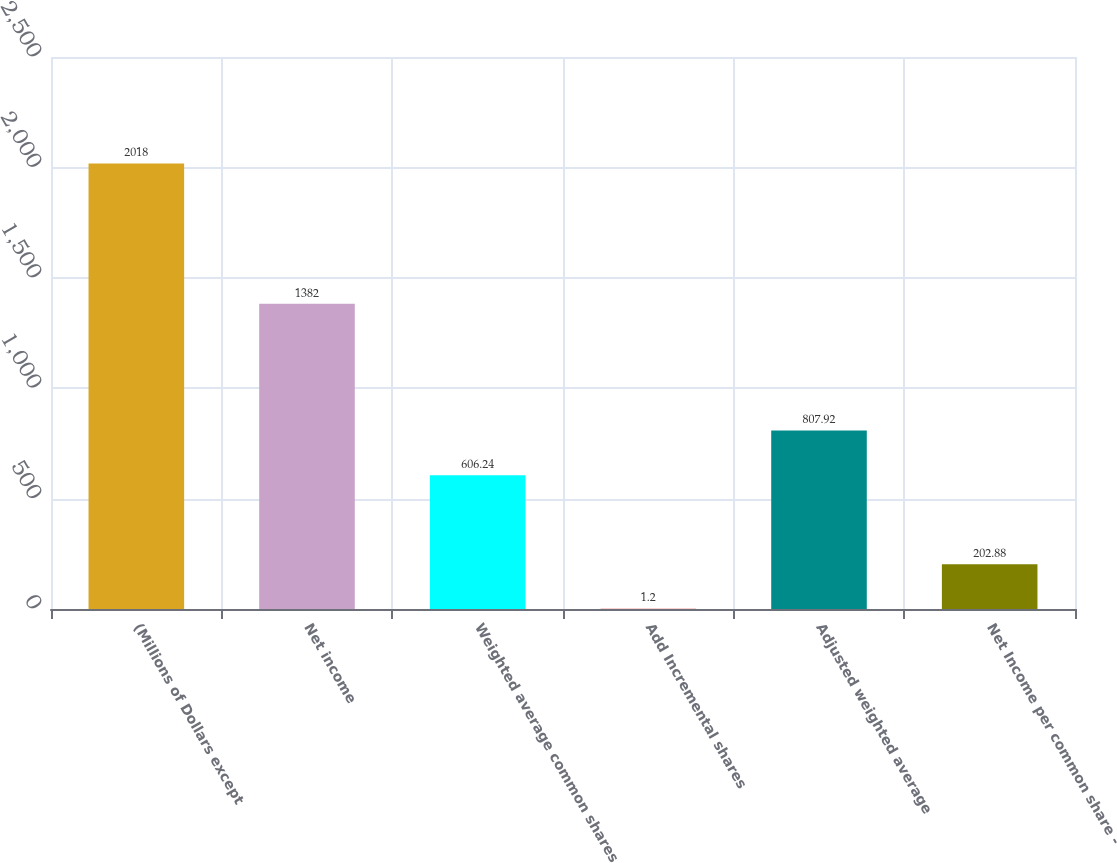Convert chart. <chart><loc_0><loc_0><loc_500><loc_500><bar_chart><fcel>(Millions of Dollars except<fcel>Net income<fcel>Weighted average common shares<fcel>Add Incremental shares<fcel>Adjusted weighted average<fcel>Net Income per common share -<nl><fcel>2018<fcel>1382<fcel>606.24<fcel>1.2<fcel>807.92<fcel>202.88<nl></chart> 